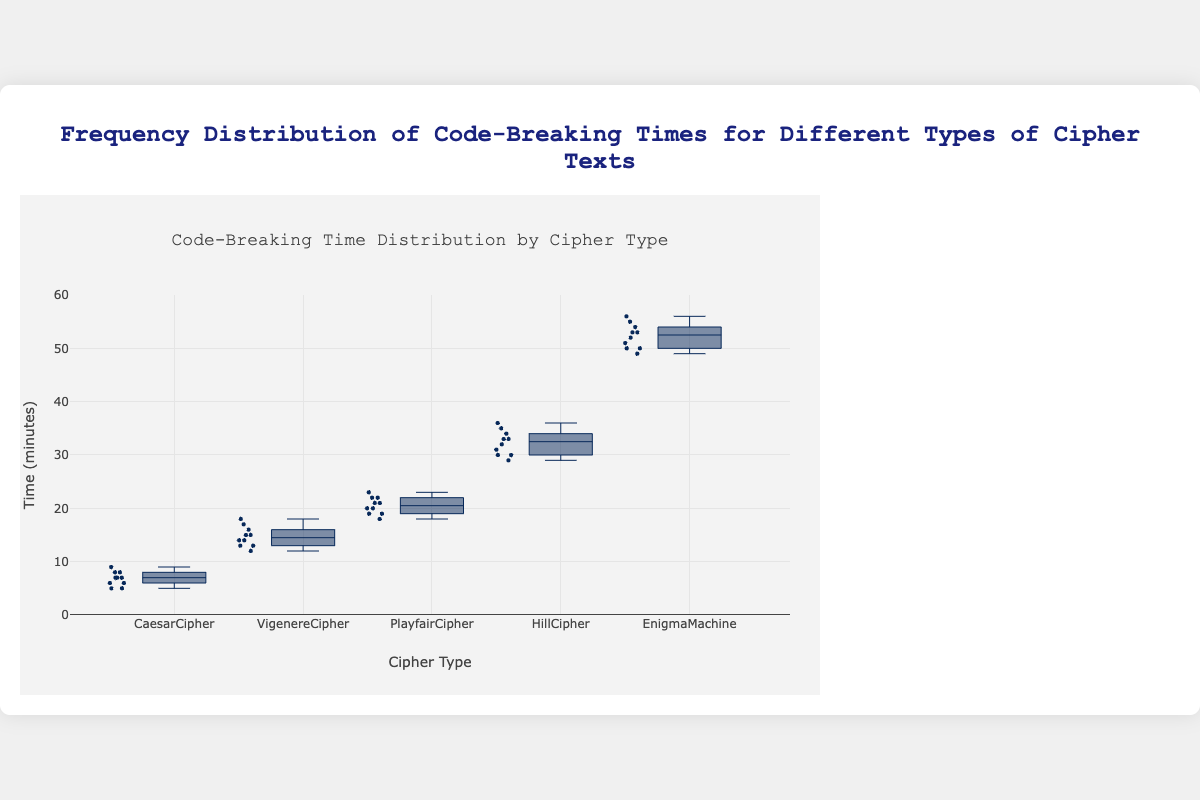What is the title of the figure? The title of the figure is displayed at the top of the chart. It provides an overall description of what the chart represents. Look at the text centered above the plot.
Answer: Frequency Distribution of Code-Breaking Times for Different Types of Cipher Texts Which axis represents time? The vertical axis (y-axis) represents time. This is indicated by the label on the left side of the chart that reads "Time (minutes)."
Answer: y-axis What is the median code-breaking time for the Caesar Cipher? To find the median code-breaking time for the Caesar Cipher, look for the horizontal line within the box for the Caesar Cipher. This line represents the median, which can be visually approximated.
Answer: 7 Which cipher has the widest range of code-breaking times? To identify the cipher with the widest range, find the box with the greatest vertical spread from its bottom whisker to its top whisker. This indicates the range of the time distribution for each cipher.
Answer: Enigma Machine How many data points are plotted for the Playfair Cipher? The data points can be counted by observing the number of individual points within or outside the box plot for the Playfair Cipher. Note that this may include the points within the box and along the whiskers.
Answer: 10 Which cipher has the smallest interquartile range (IQR)? The interquartile range is the height of the box itself. Find the box that is the shortest from top to bottom. This represents the smallest IQR.
Answer: Caesar Cipher What is the average code-breaking time for the Vigenere Cipher? Sum all the code-breaking times for the Vigenere Cipher (12 + 15 + 13 + 18 + 16 + 14 + 15 + 14 + 17 + 13) and divide by the number of values (10) to find the average.
Answer: 14.7 What is the median value for the Hill Cipher? To find this, identify the middle value from the Hill Cipher's data points by locating the line in the box plot for the Hill Cipher that indicates the median.
Answer: 32.5 Compare the maximum code-breaking times for the Vigenere and Playfair Ciphers. Which one is higher? Identify the top whisker for both the Vigenere Cipher and Playfair Cipher. The Playfair Cipher's top whisker reaches 23, while the Vigenere Cipher's top whisker reaches 18.
Answer: Playfair Cipher Which cipher has the lowest minimum code-breaking time? To determine this, look for the whisker that extends the lowest among all the ciphers. The cipher with the bottom whisker at the lowest point has the lowest minimum time.
Answer: Caesar Cipher 